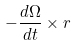Convert formula to latex. <formula><loc_0><loc_0><loc_500><loc_500>- { \frac { d { \Omega } } { d t } } \times r</formula> 